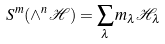Convert formula to latex. <formula><loc_0><loc_0><loc_500><loc_500>S ^ { m } ( \wedge ^ { n } \mathcal { H } ) = \sum _ { \lambda } m _ { \lambda } \mathcal { H } _ { \lambda }</formula> 